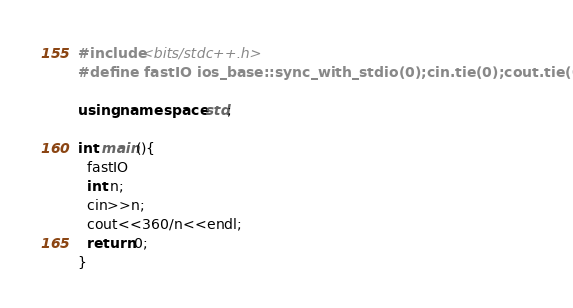Convert code to text. <code><loc_0><loc_0><loc_500><loc_500><_C++_>#include<bits/stdc++.h>
#define fastIO ios_base::sync_with_stdio(0);cin.tie(0);cout.tie(0);

using namespace std;

int main(){
  fastIO
  int n;
  cin>>n;
  cout<<360/n<<endl;
  return 0;
}</code> 